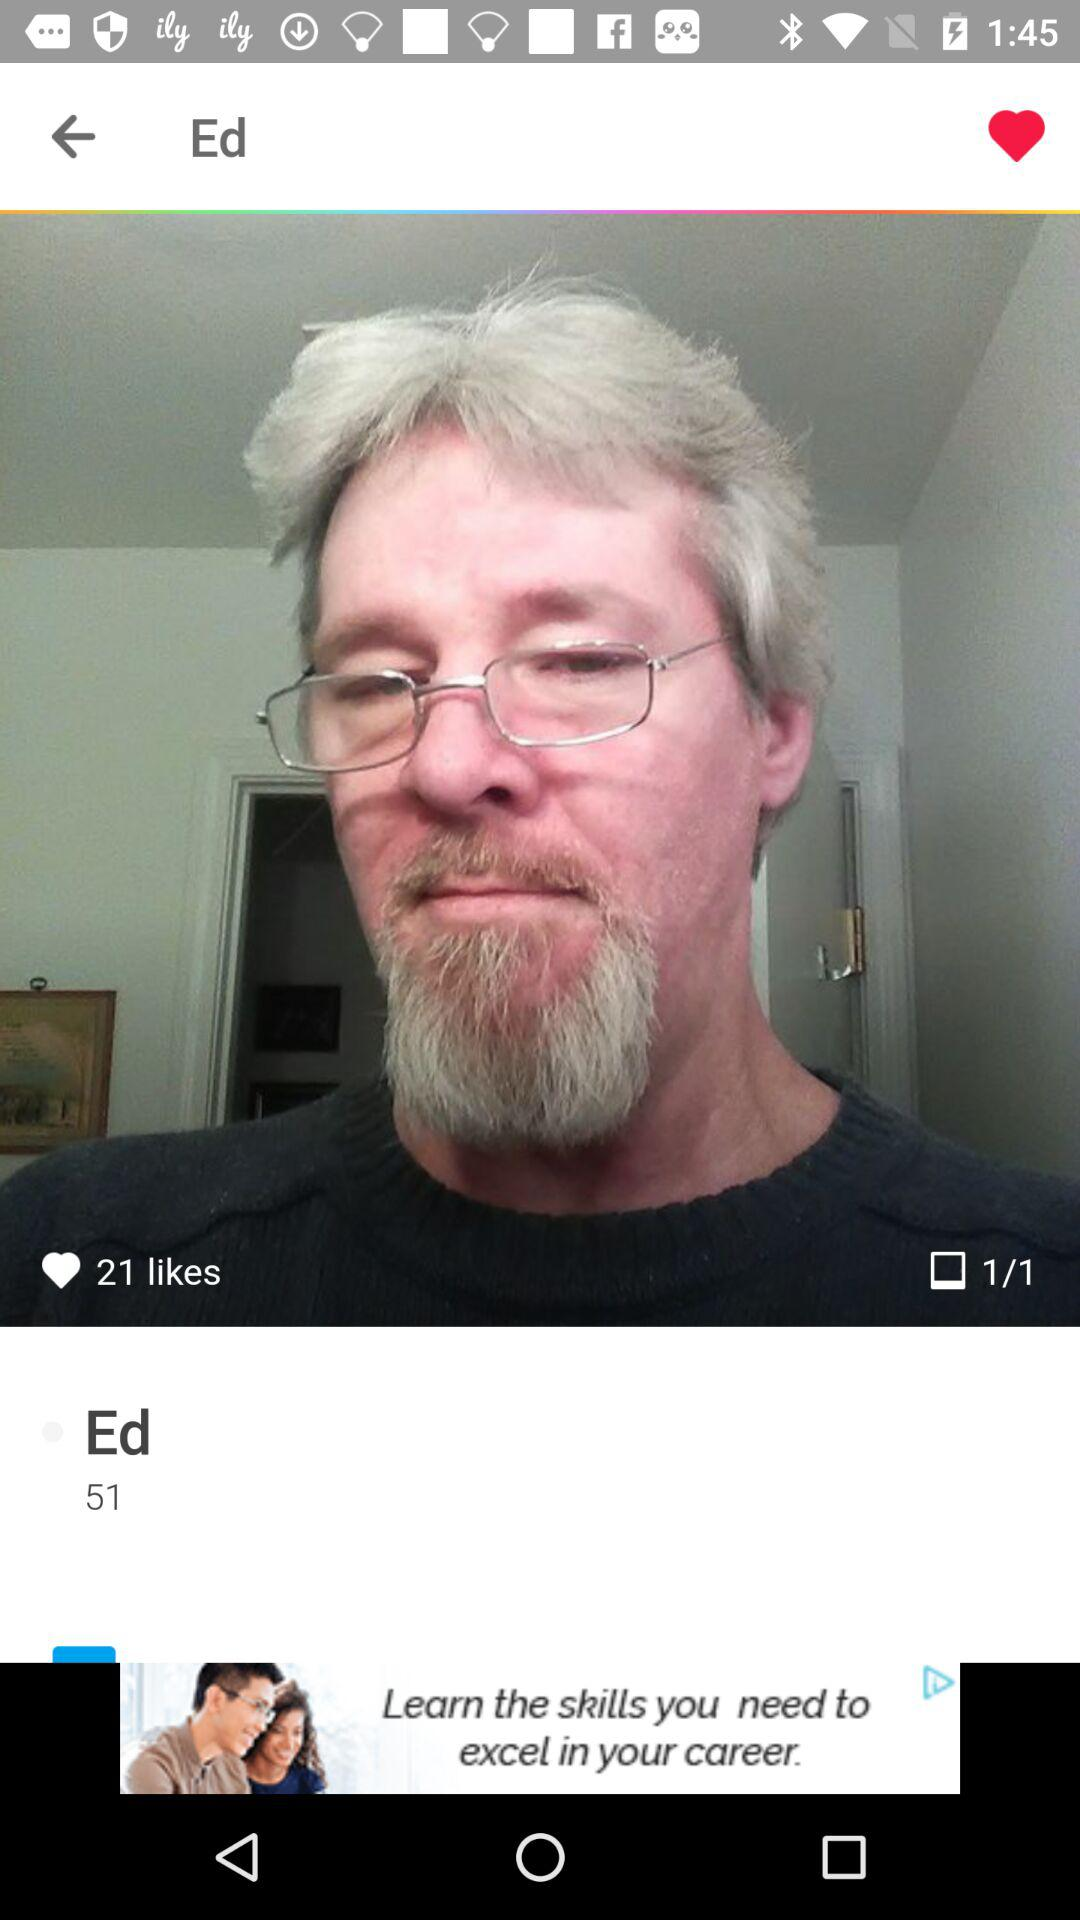What is the name of the person? The name of the person is Ed. 